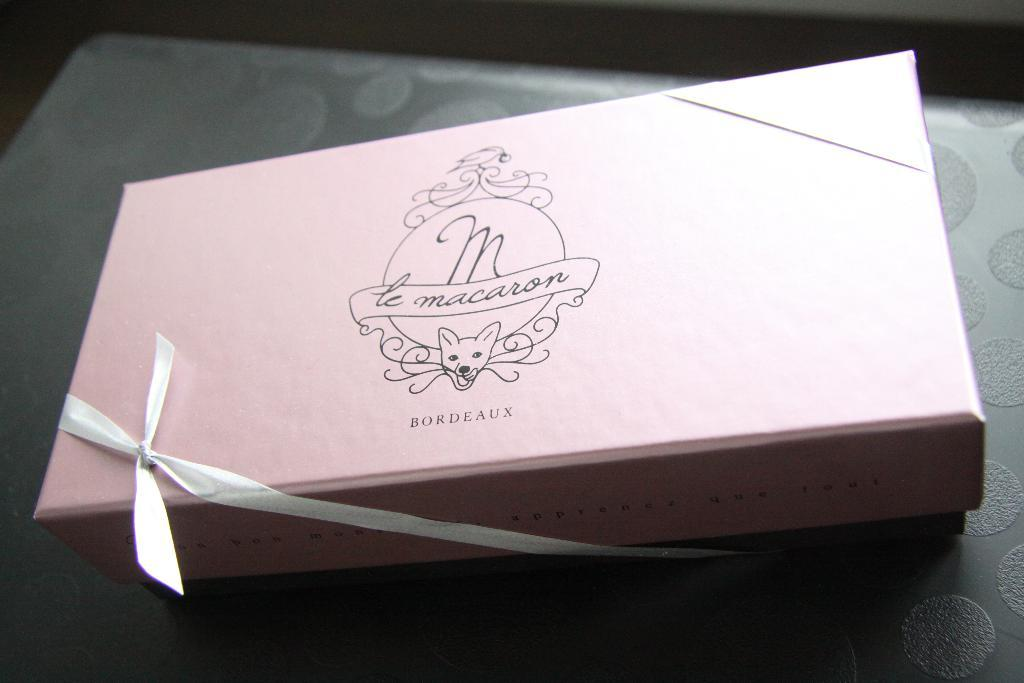Provide a one-sentence caption for the provided image. A gifted packaged of maracon bordeaux is placed on the table. 